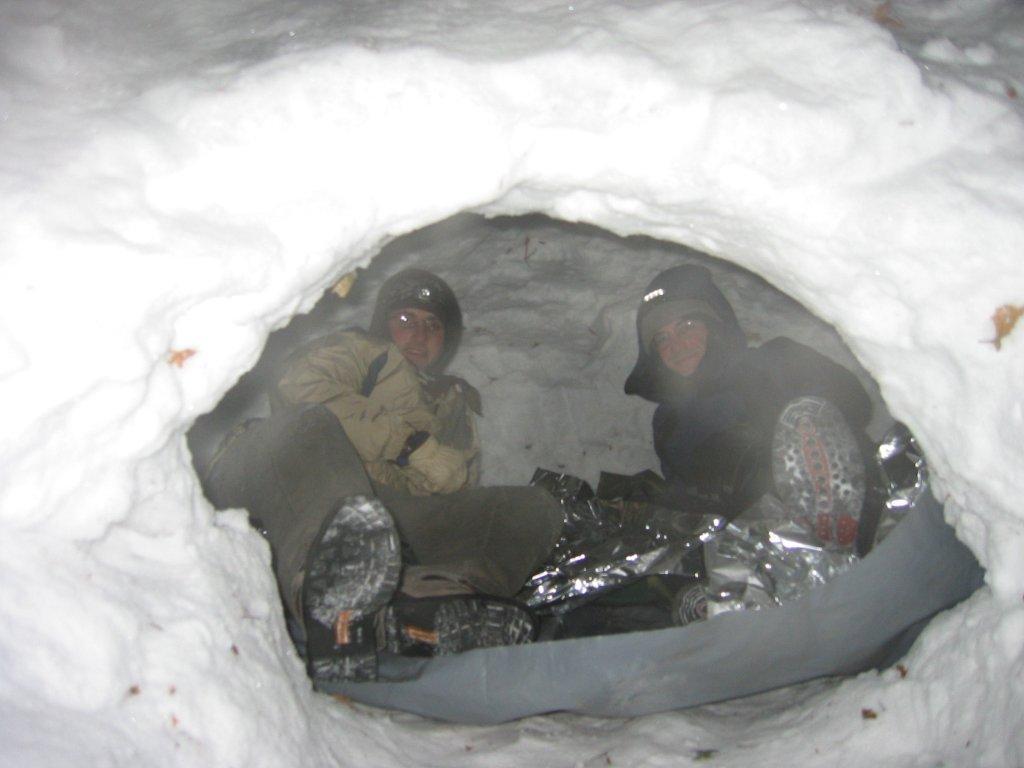Could you give a brief overview of what you see in this image? In this picture there are two men sitting and there are few objects. We can see snow. 